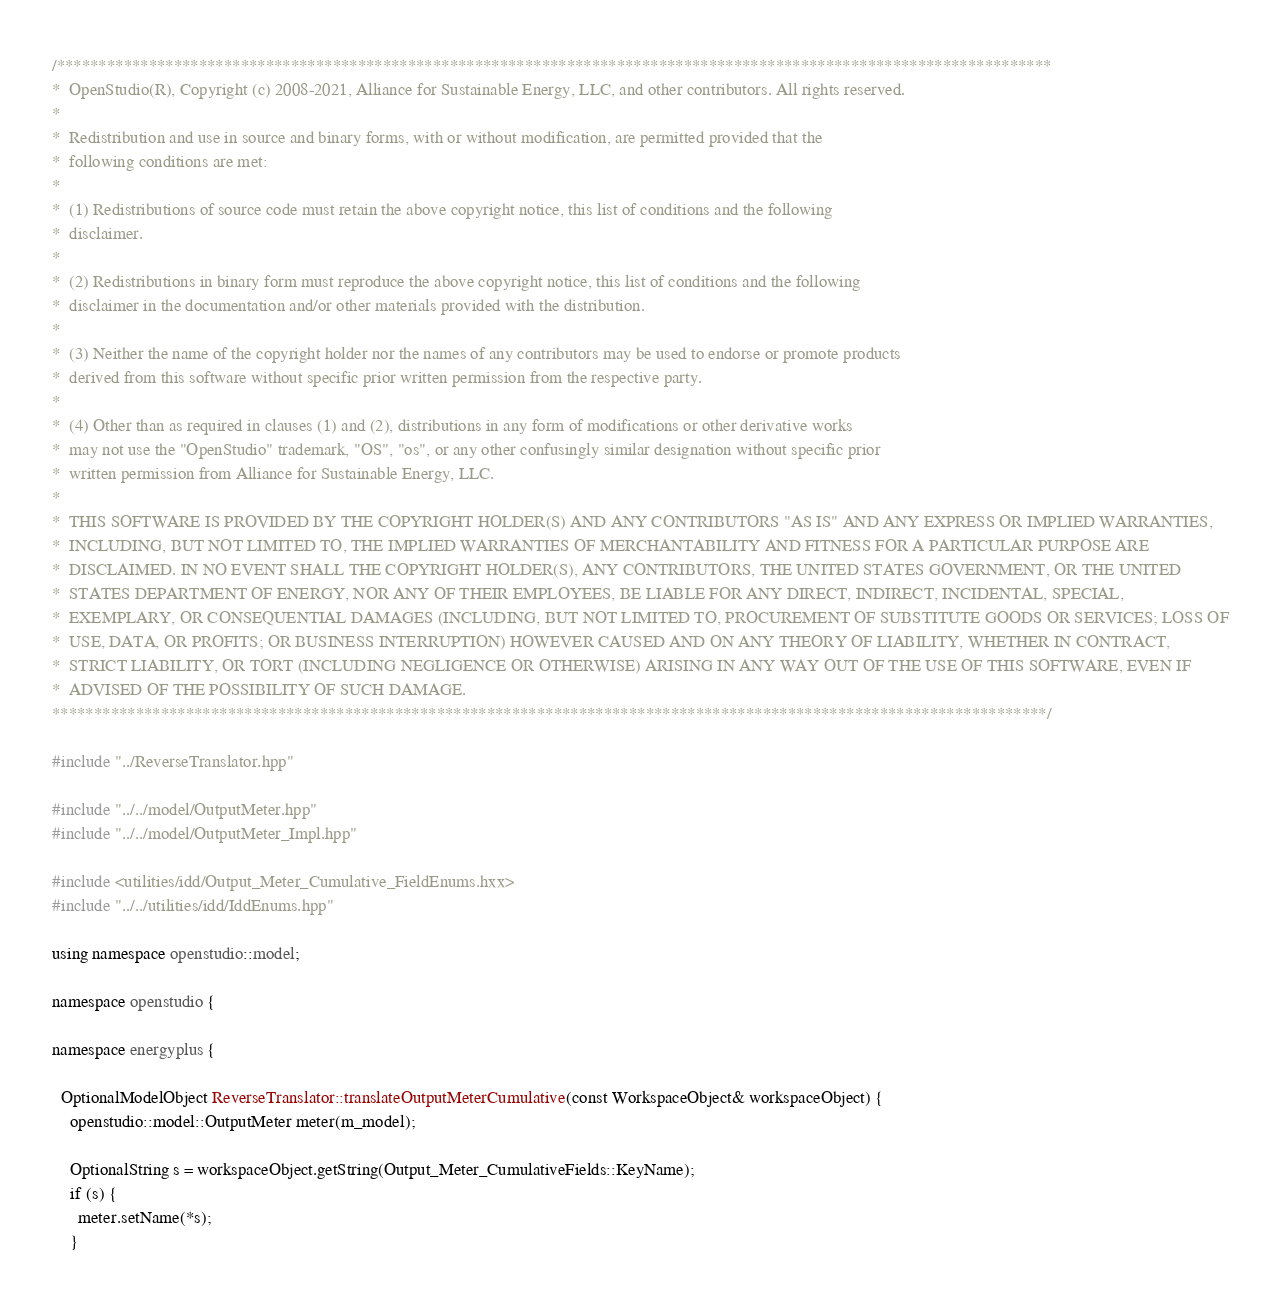<code> <loc_0><loc_0><loc_500><loc_500><_C++_>/***********************************************************************************************************************
*  OpenStudio(R), Copyright (c) 2008-2021, Alliance for Sustainable Energy, LLC, and other contributors. All rights reserved.
*
*  Redistribution and use in source and binary forms, with or without modification, are permitted provided that the
*  following conditions are met:
*
*  (1) Redistributions of source code must retain the above copyright notice, this list of conditions and the following
*  disclaimer.
*
*  (2) Redistributions in binary form must reproduce the above copyright notice, this list of conditions and the following
*  disclaimer in the documentation and/or other materials provided with the distribution.
*
*  (3) Neither the name of the copyright holder nor the names of any contributors may be used to endorse or promote products
*  derived from this software without specific prior written permission from the respective party.
*
*  (4) Other than as required in clauses (1) and (2), distributions in any form of modifications or other derivative works
*  may not use the "OpenStudio" trademark, "OS", "os", or any other confusingly similar designation without specific prior
*  written permission from Alliance for Sustainable Energy, LLC.
*
*  THIS SOFTWARE IS PROVIDED BY THE COPYRIGHT HOLDER(S) AND ANY CONTRIBUTORS "AS IS" AND ANY EXPRESS OR IMPLIED WARRANTIES,
*  INCLUDING, BUT NOT LIMITED TO, THE IMPLIED WARRANTIES OF MERCHANTABILITY AND FITNESS FOR A PARTICULAR PURPOSE ARE
*  DISCLAIMED. IN NO EVENT SHALL THE COPYRIGHT HOLDER(S), ANY CONTRIBUTORS, THE UNITED STATES GOVERNMENT, OR THE UNITED
*  STATES DEPARTMENT OF ENERGY, NOR ANY OF THEIR EMPLOYEES, BE LIABLE FOR ANY DIRECT, INDIRECT, INCIDENTAL, SPECIAL,
*  EXEMPLARY, OR CONSEQUENTIAL DAMAGES (INCLUDING, BUT NOT LIMITED TO, PROCUREMENT OF SUBSTITUTE GOODS OR SERVICES; LOSS OF
*  USE, DATA, OR PROFITS; OR BUSINESS INTERRUPTION) HOWEVER CAUSED AND ON ANY THEORY OF LIABILITY, WHETHER IN CONTRACT,
*  STRICT LIABILITY, OR TORT (INCLUDING NEGLIGENCE OR OTHERWISE) ARISING IN ANY WAY OUT OF THE USE OF THIS SOFTWARE, EVEN IF
*  ADVISED OF THE POSSIBILITY OF SUCH DAMAGE.
***********************************************************************************************************************/

#include "../ReverseTranslator.hpp"

#include "../../model/OutputMeter.hpp"
#include "../../model/OutputMeter_Impl.hpp"

#include <utilities/idd/Output_Meter_Cumulative_FieldEnums.hxx>
#include "../../utilities/idd/IddEnums.hpp"

using namespace openstudio::model;

namespace openstudio {

namespace energyplus {

  OptionalModelObject ReverseTranslator::translateOutputMeterCumulative(const WorkspaceObject& workspaceObject) {
    openstudio::model::OutputMeter meter(m_model);

    OptionalString s = workspaceObject.getString(Output_Meter_CumulativeFields::KeyName);
    if (s) {
      meter.setName(*s);
    }
</code> 